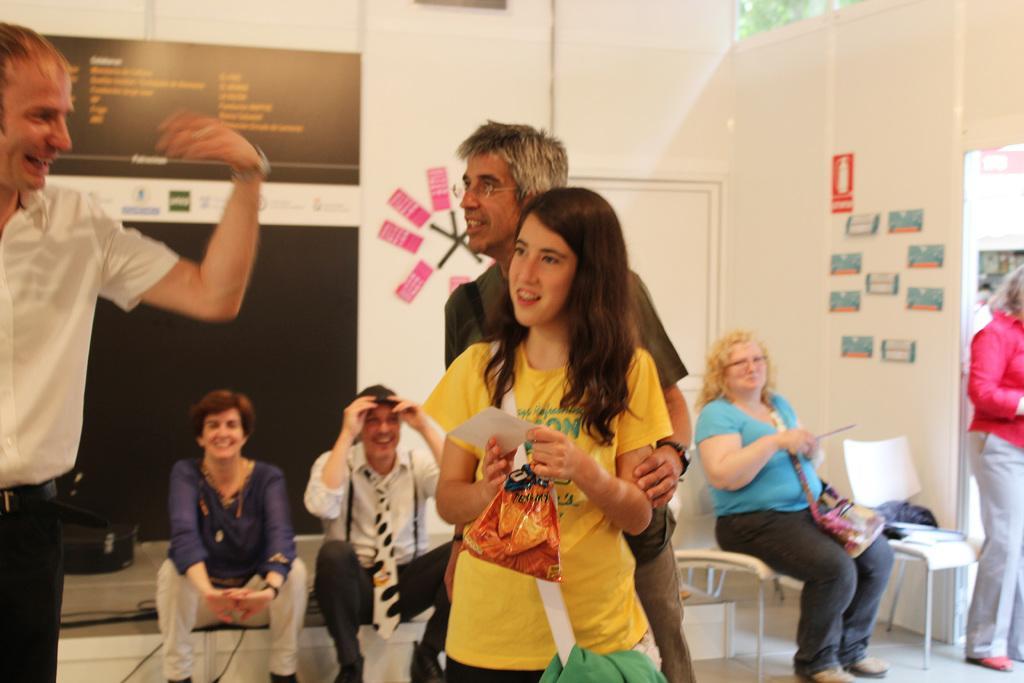In one or two sentences, can you explain what this image depicts? In this picture we can see a group of people,some people are sitting on chairs,some people are standing and in the background we can see a wall. 